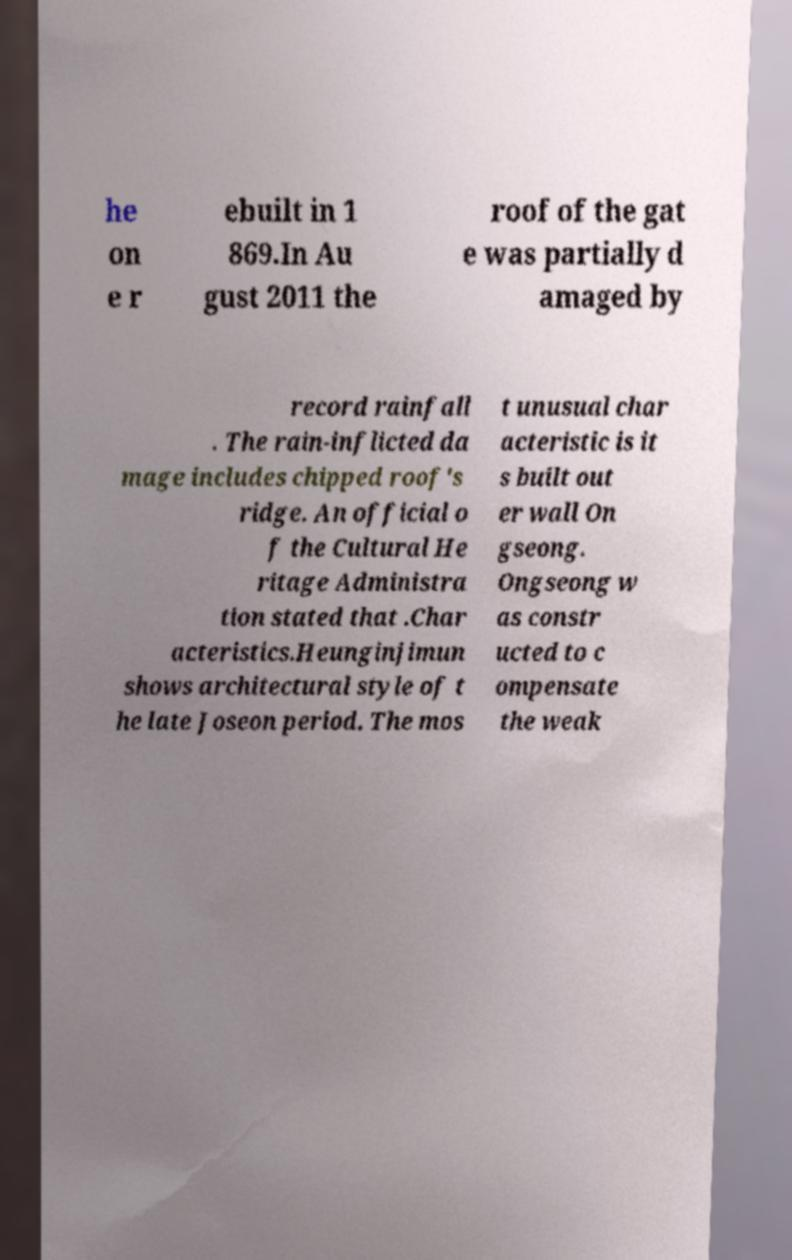Could you assist in decoding the text presented in this image and type it out clearly? he on e r ebuilt in 1 869.In Au gust 2011 the roof of the gat e was partially d amaged by record rainfall . The rain-inflicted da mage includes chipped roof's ridge. An official o f the Cultural He ritage Administra tion stated that .Char acteristics.Heunginjimun shows architectural style of t he late Joseon period. The mos t unusual char acteristic is it s built out er wall On gseong. Ongseong w as constr ucted to c ompensate the weak 